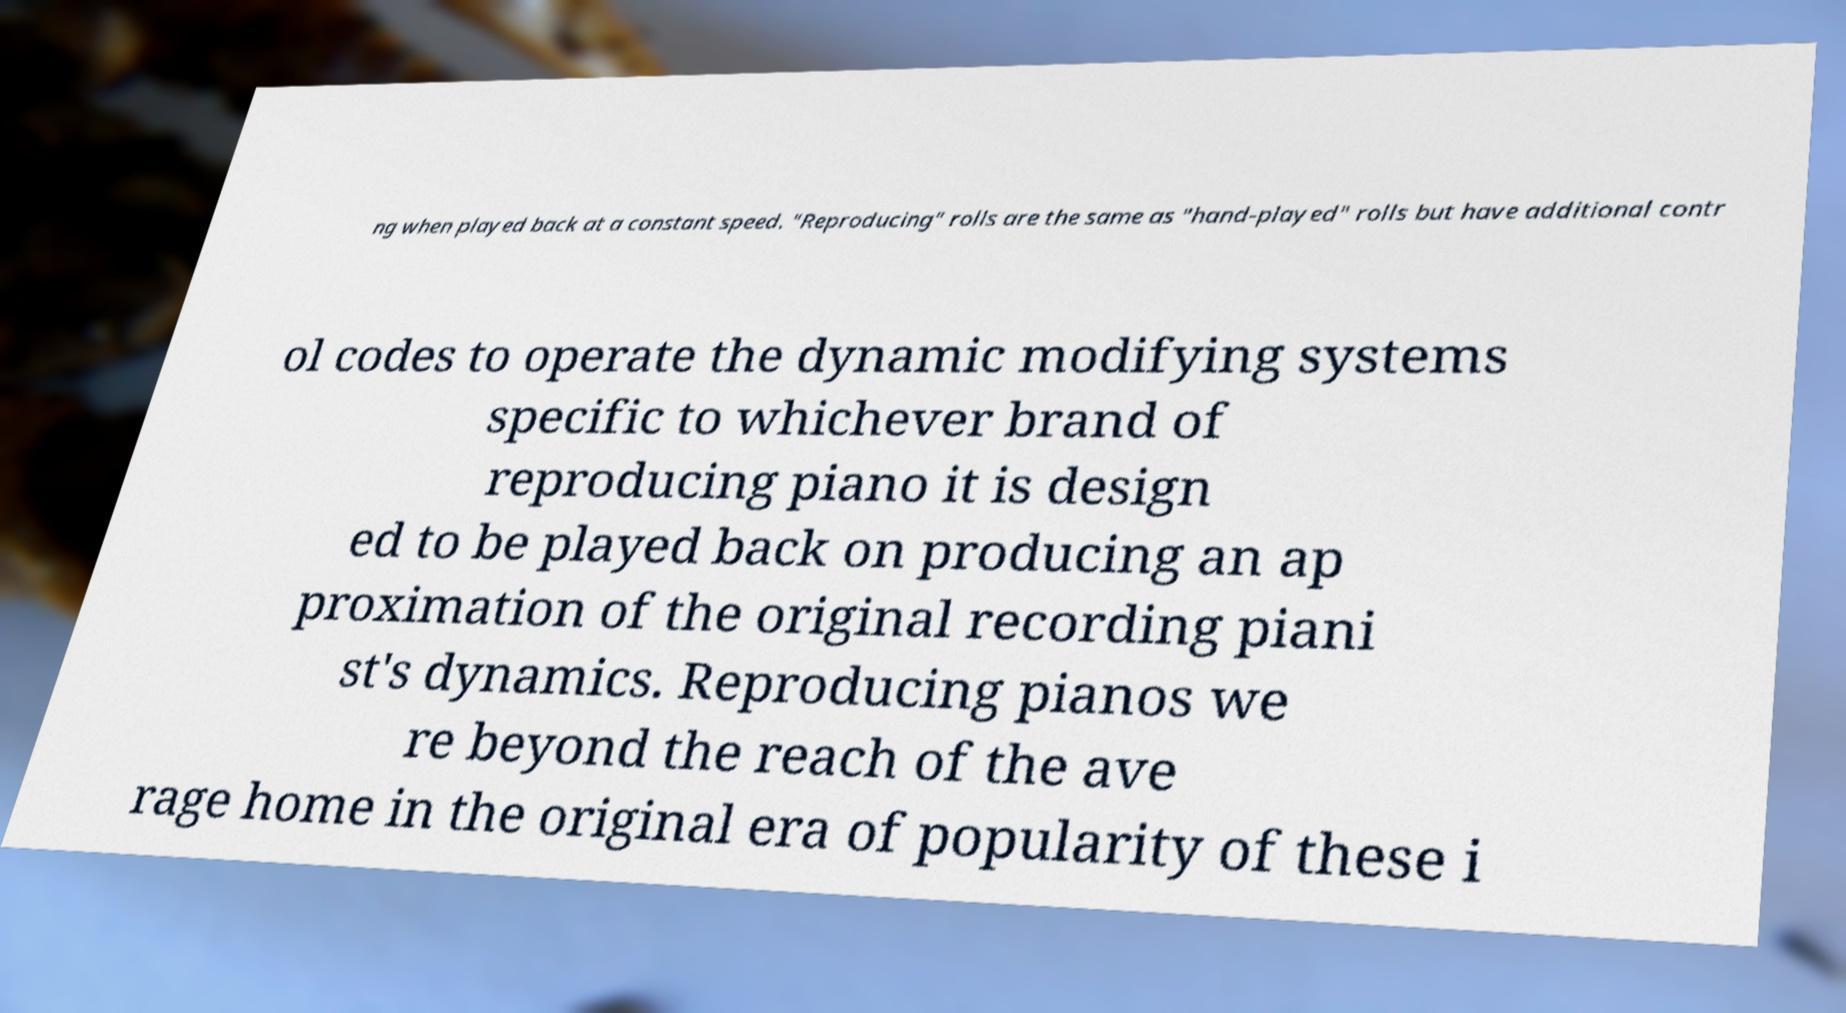Could you extract and type out the text from this image? ng when played back at a constant speed. "Reproducing" rolls are the same as "hand-played" rolls but have additional contr ol codes to operate the dynamic modifying systems specific to whichever brand of reproducing piano it is design ed to be played back on producing an ap proximation of the original recording piani st's dynamics. Reproducing pianos we re beyond the reach of the ave rage home in the original era of popularity of these i 